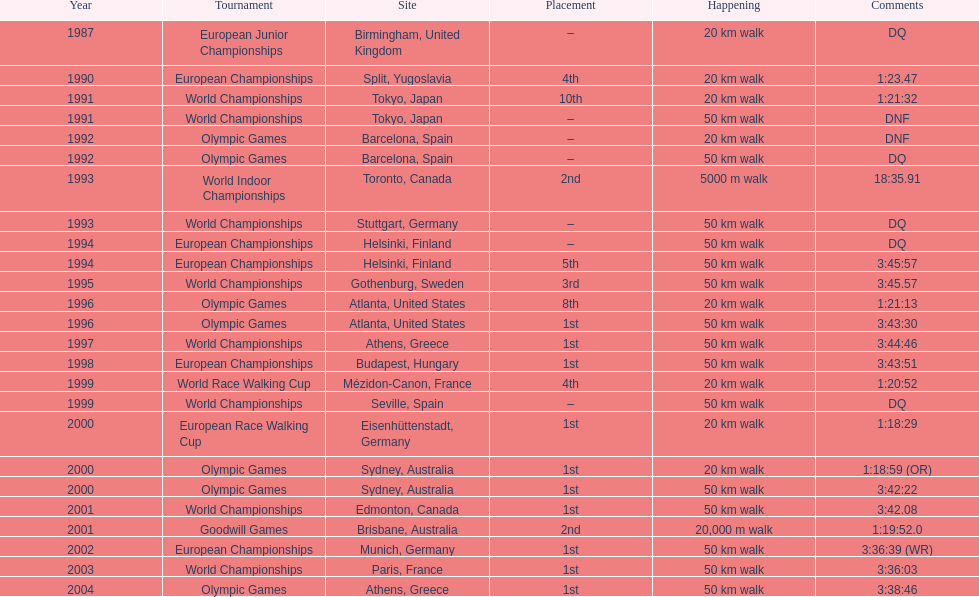What was the name of the competition that took place before the olympic games in 1996? World Championships. 